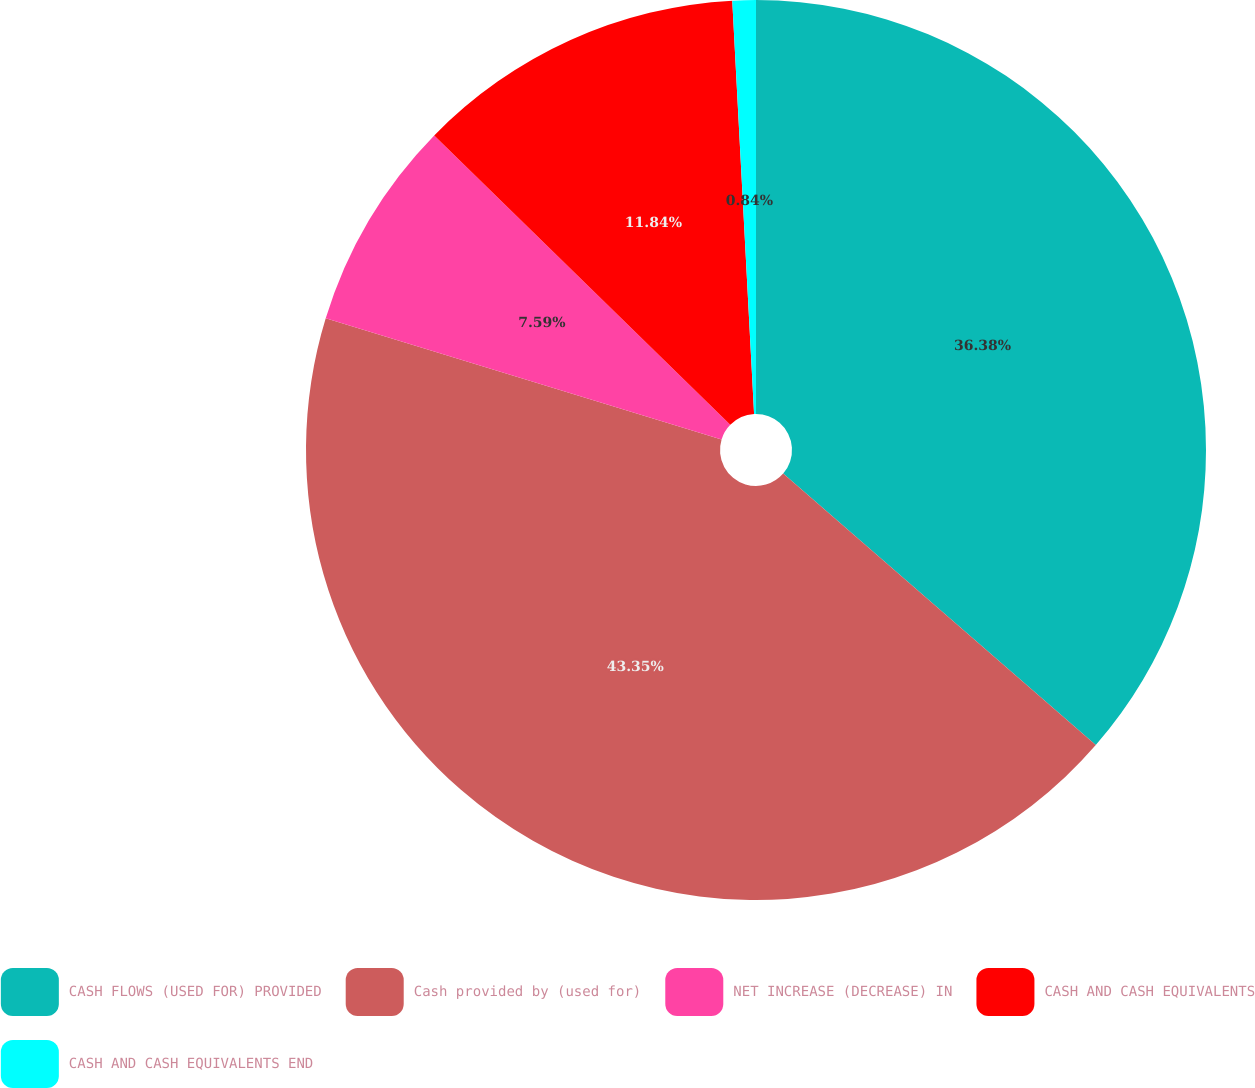Convert chart. <chart><loc_0><loc_0><loc_500><loc_500><pie_chart><fcel>CASH FLOWS (USED FOR) PROVIDED<fcel>Cash provided by (used for)<fcel>NET INCREASE (DECREASE) IN<fcel>CASH AND CASH EQUIVALENTS<fcel>CASH AND CASH EQUIVALENTS END<nl><fcel>36.38%<fcel>43.35%<fcel>7.59%<fcel>11.84%<fcel>0.84%<nl></chart> 